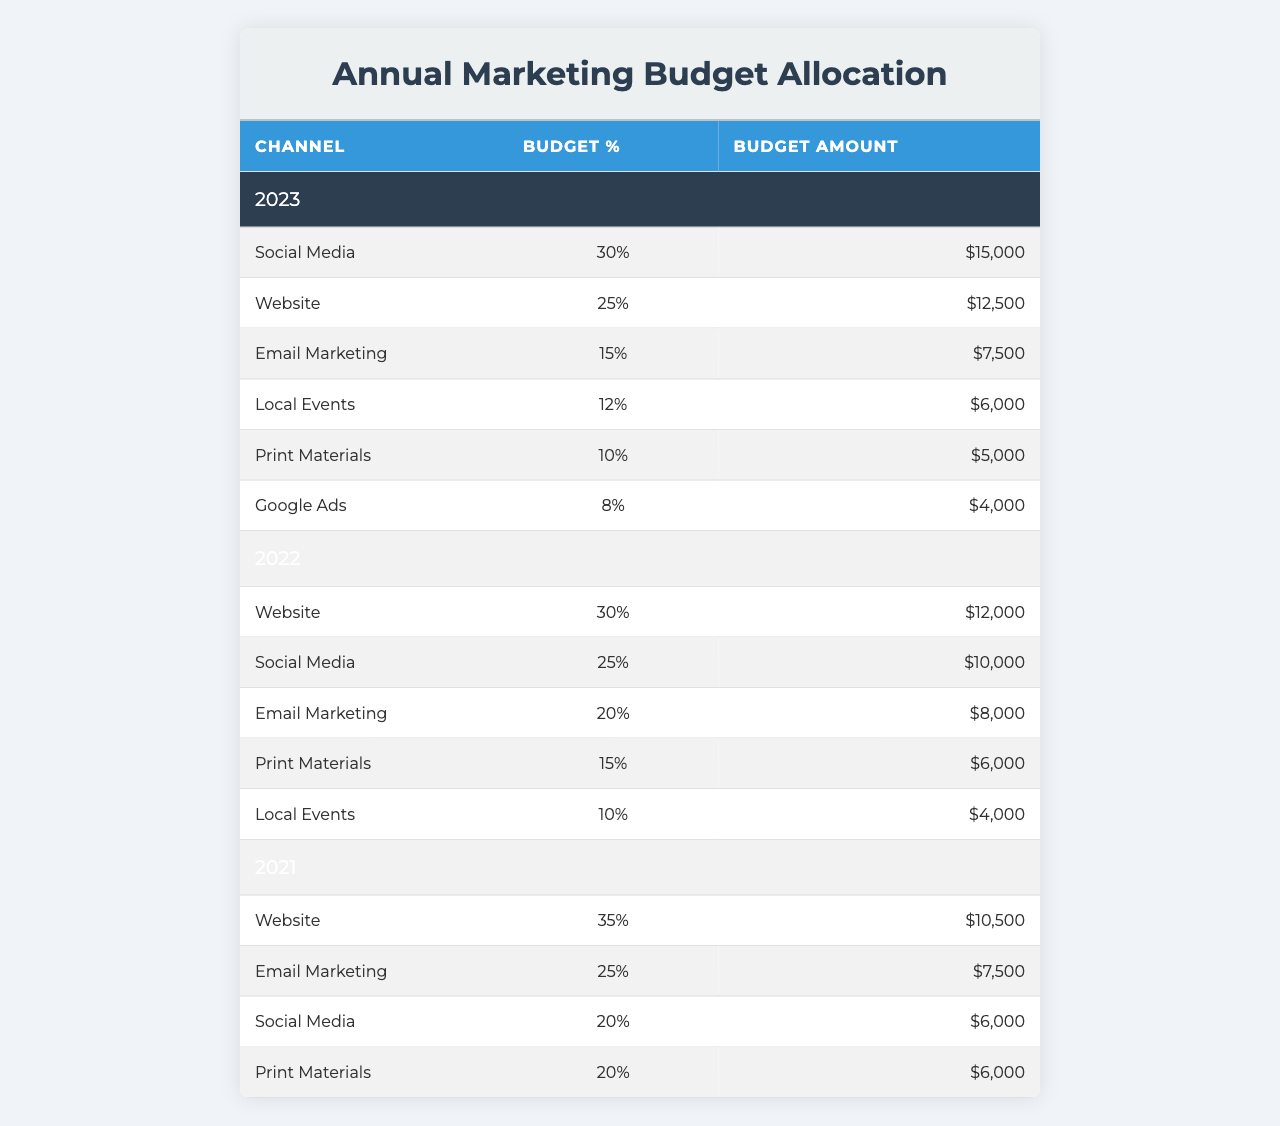What is the budget allocation percentage for Social Media in 2023? In the table, for the year 2023, the Social Media channel has a Budget_Percentage of 30%.
Answer: 30% How much was allocated to Email Marketing in 2022? Looking at the 2022 row for Email Marketing, the Budget_Amount shown is $8,000.
Answer: $8,000 Which marketing channel received the lowest budget amount in 2023? The Google Ads channel in 2023 has the lowest Budget_Amount of $4,000, compared to the other channels listed.
Answer: Google Ads What is the combined budget amount for Print Materials across all three years? Adding the budget amounts for Print Materials: 2023 ($5,000) + 2022 ($6,000) + 2021 ($6,000) equals a total of $17,000.
Answer: $17,000 Did the budget percentage for Social Media increase from 2021 to 2023? In 2021, the budget percentage for Social Media was 20%, while in 2023 it increased to 30%, indicating a positive change.
Answer: Yes What is the average budget percentage allocated to Website across all three years? The Website budget percentages are 25% (2023), 30% (2022), and 35% (2021). Adding these gives 90%, and dividing by 3 results in an average of 30%.
Answer: 30% Which year had a higher budget allocation for Local Events, 2022 or 2023? In 2022, the budget for Local Events was $4,000, while in 2023 it was $6,000, indicating that 2023 had the higher allocation.
Answer: 2023 What was the total budget amount for all channels in 2021? The total budget for 2021 can be calculated by summing the amounts: $6,000 (Social Media) + $10,500 (Website) + $7,500 (Email Marketing) + $6,000 (Print Materials) = $30,000.
Answer: $30,000 Is it true that the budget amount for Google Ads increased from 2022 to 2023? In 2022, Google Ads had a budget amount of $4,000, and there is no entry for 2023 indicating a change; thus, the statement is true.
Answer: False What is the difference in budget amount between the highest and lowest channel allocation in 2023? In 2023, the highest allocation was for Social Media at $15,000, and the lowest for Google Ads at $4,000. The difference is $15,000 - $4,000 = $11,000.
Answer: $11,000 